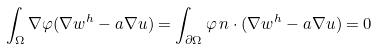<formula> <loc_0><loc_0><loc_500><loc_500>\int _ { \Omega } \nabla \varphi ( \nabla w ^ { h } - a \nabla u ) = \int _ { \partial \Omega } \varphi \, n \cdot ( \nabla w ^ { h } - a \nabla u ) = 0</formula> 